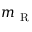<formula> <loc_0><loc_0><loc_500><loc_500>m _ { R }</formula> 